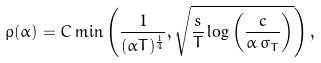<formula> <loc_0><loc_0><loc_500><loc_500>\rho ( \alpha ) = C \min \left ( \frac { 1 } { ( \alpha T ) ^ { \frac { 1 } { 4 } } } , \sqrt { \frac { s } { T } \log \left ( \frac { c } { \alpha \, \sigma _ { T } } \right ) } \right ) ,</formula> 